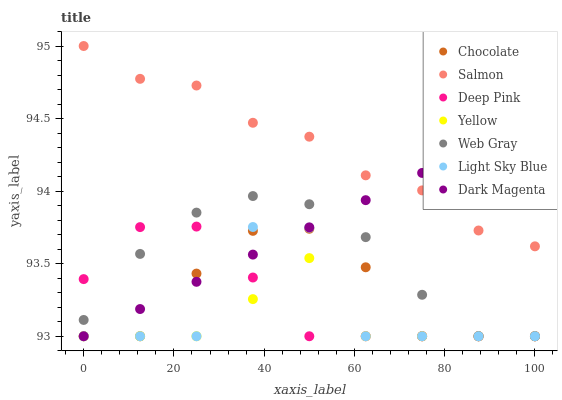Does Yellow have the minimum area under the curve?
Answer yes or no. Yes. Does Salmon have the maximum area under the curve?
Answer yes or no. Yes. Does Dark Magenta have the minimum area under the curve?
Answer yes or no. No. Does Dark Magenta have the maximum area under the curve?
Answer yes or no. No. Is Dark Magenta the smoothest?
Answer yes or no. Yes. Is Light Sky Blue the roughest?
Answer yes or no. Yes. Is Salmon the smoothest?
Answer yes or no. No. Is Salmon the roughest?
Answer yes or no. No. Does Web Gray have the lowest value?
Answer yes or no. Yes. Does Salmon have the lowest value?
Answer yes or no. No. Does Salmon have the highest value?
Answer yes or no. Yes. Does Dark Magenta have the highest value?
Answer yes or no. No. Is Deep Pink less than Salmon?
Answer yes or no. Yes. Is Salmon greater than Deep Pink?
Answer yes or no. Yes. Does Chocolate intersect Light Sky Blue?
Answer yes or no. Yes. Is Chocolate less than Light Sky Blue?
Answer yes or no. No. Is Chocolate greater than Light Sky Blue?
Answer yes or no. No. Does Deep Pink intersect Salmon?
Answer yes or no. No. 